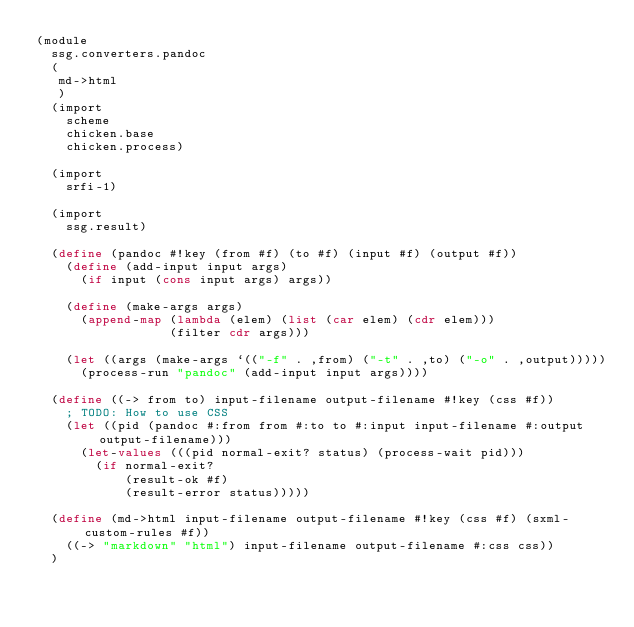<code> <loc_0><loc_0><loc_500><loc_500><_Scheme_>(module
  ssg.converters.pandoc
  (
   md->html
   )
  (import
    scheme
    chicken.base
    chicken.process)

  (import
    srfi-1)

  (import
    ssg.result)

  (define (pandoc #!key (from #f) (to #f) (input #f) (output #f))
    (define (add-input input args)
      (if input (cons input args) args))

    (define (make-args args)
      (append-map (lambda (elem) (list (car elem) (cdr elem)))
                  (filter cdr args)))

    (let ((args (make-args `(("-f" . ,from) ("-t" . ,to) ("-o" . ,output)))))
      (process-run "pandoc" (add-input input args))))

  (define ((-> from to) input-filename output-filename #!key (css #f))
    ; TODO: How to use CSS
    (let ((pid (pandoc #:from from #:to to #:input input-filename #:output output-filename)))
      (let-values (((pid normal-exit? status) (process-wait pid)))
        (if normal-exit?
            (result-ok #f)
            (result-error status)))))

  (define (md->html input-filename output-filename #!key (css #f) (sxml-custom-rules #f))
    ((-> "markdown" "html") input-filename output-filename #:css css))
  )
</code> 